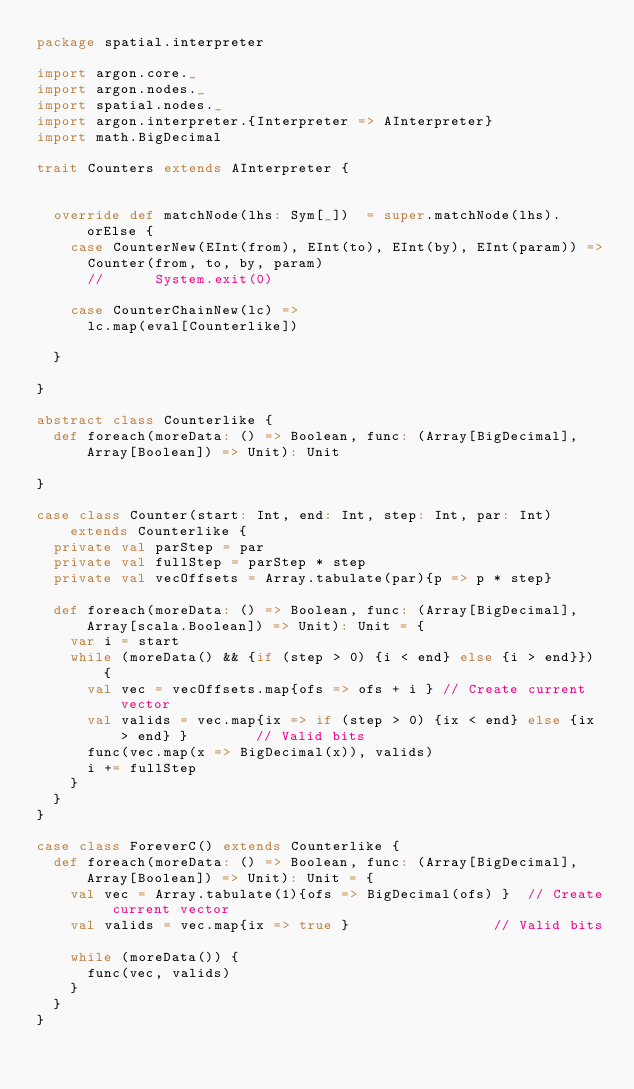<code> <loc_0><loc_0><loc_500><loc_500><_Scala_>package spatial.interpreter

import argon.core._
import argon.nodes._
import spatial.nodes._
import argon.interpreter.{Interpreter => AInterpreter}
import math.BigDecimal

trait Counters extends AInterpreter {


  override def matchNode(lhs: Sym[_])  = super.matchNode(lhs).orElse {
    case CounterNew(EInt(from), EInt(to), EInt(by), EInt(param)) =>
      Counter(from, to, by, param)
      //      System.exit(0)

    case CounterChainNew(lc) =>
      lc.map(eval[Counterlike])

  }

}

abstract class Counterlike {
  def foreach(moreData: () => Boolean, func: (Array[BigDecimal],Array[Boolean]) => Unit): Unit
  
}

case class Counter(start: Int, end: Int, step: Int, par: Int) extends Counterlike {
  private val parStep = par
  private val fullStep = parStep * step
  private val vecOffsets = Array.tabulate(par){p => p * step}

  def foreach(moreData: () => Boolean, func: (Array[BigDecimal],Array[scala.Boolean]) => Unit): Unit = {
    var i = start
    while (moreData() && {if (step > 0) {i < end} else {i > end}}) {
      val vec = vecOffsets.map{ofs => ofs + i } // Create current vector
      val valids = vec.map{ix => if (step > 0) {ix < end} else {ix > end} }        // Valid bits
      func(vec.map(x => BigDecimal(x)), valids)
      i += fullStep
    }
  }
}

case class ForeverC() extends Counterlike {
  def foreach(moreData: () => Boolean, func: (Array[BigDecimal],Array[Boolean]) => Unit): Unit = {
    val vec = Array.tabulate(1){ofs => BigDecimal(ofs) }  // Create current vector
    val valids = vec.map{ix => true }                 // Valid bits

    while (moreData()) {
      func(vec, valids)
    }
  }
}

</code> 